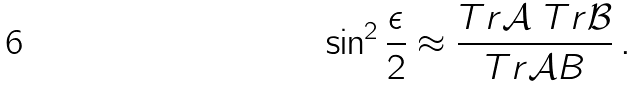<formula> <loc_0><loc_0><loc_500><loc_500>\sin ^ { 2 } \frac { \epsilon } { 2 } \approx \frac { T r { \mathcal { A } } \ T r { \mathcal { B } } } { T r { \mathcal { A } B } } \, .</formula> 